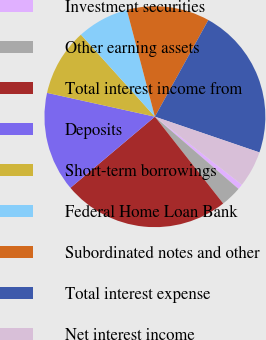<chart> <loc_0><loc_0><loc_500><loc_500><pie_chart><fcel>Investment securities<fcel>Other earning assets<fcel>Total interest income from<fcel>Deposits<fcel>Short-term borrowings<fcel>Federal Home Loan Bank<fcel>Subordinated notes and other<fcel>Total interest expense<fcel>Net interest income<nl><fcel>0.78%<fcel>3.05%<fcel>24.47%<fcel>14.6%<fcel>9.86%<fcel>7.59%<fcel>12.13%<fcel>22.2%<fcel>5.32%<nl></chart> 